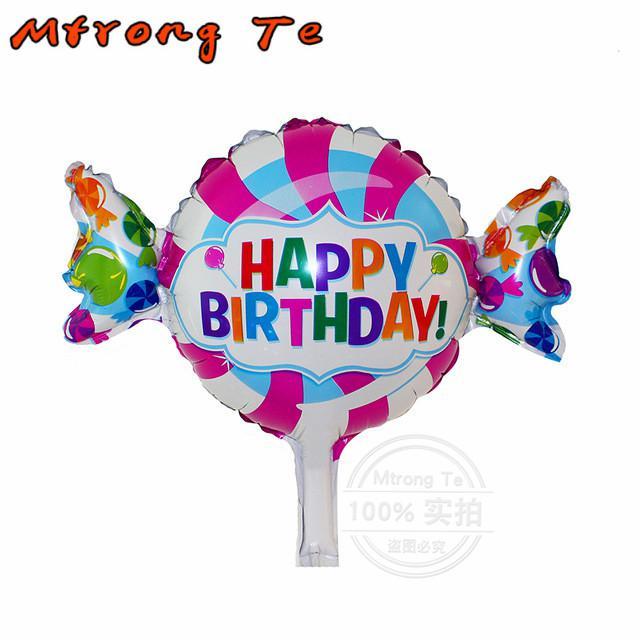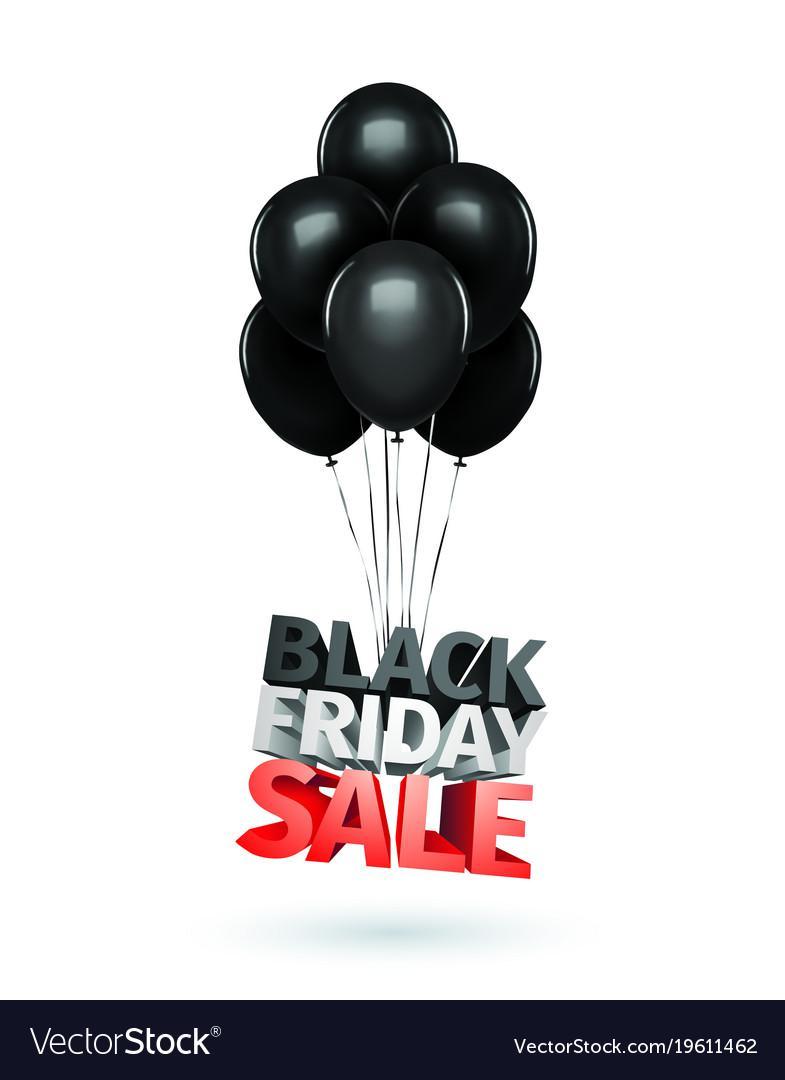The first image is the image on the left, the second image is the image on the right. Examine the images to the left and right. Is the description "There are no more than seven balloons with at least one looking like a piece of wrapped candy." accurate? Answer yes or no. Yes. The first image is the image on the left, the second image is the image on the right. Examine the images to the left and right. Is the description "There is a single balloon in the left image." accurate? Answer yes or no. Yes. 